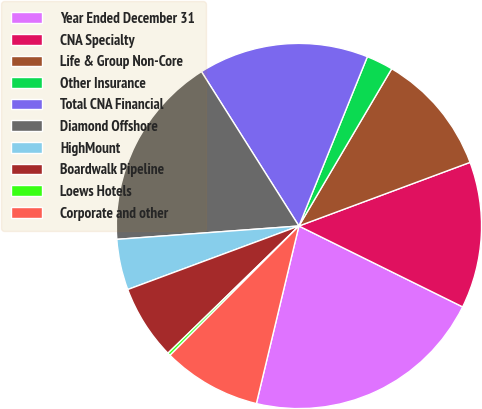Convert chart. <chart><loc_0><loc_0><loc_500><loc_500><pie_chart><fcel>Year Ended December 31<fcel>CNA Specialty<fcel>Life & Group Non-Core<fcel>Other Insurance<fcel>Total CNA Financial<fcel>Diamond Offshore<fcel>HighMount<fcel>Boardwalk Pipeline<fcel>Loews Hotels<fcel>Corporate and other<nl><fcel>21.44%<fcel>12.97%<fcel>10.85%<fcel>2.37%<fcel>15.08%<fcel>17.2%<fcel>4.49%<fcel>6.61%<fcel>0.26%<fcel>8.73%<nl></chart> 